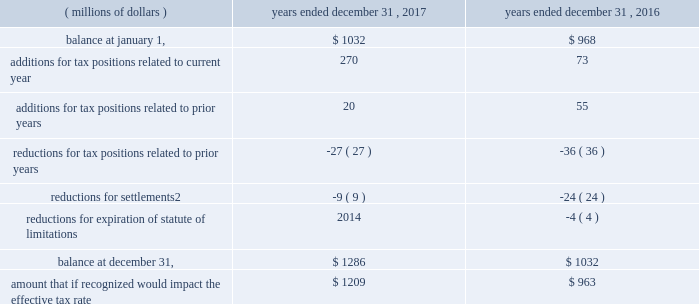82 | 2017 form 10-k a reconciliation of the beginning and ending amount of gross unrecognized tax benefits for uncertain tax positions , including positions impacting only the timing of tax benefits , follows .
Reconciliation of unrecognized tax benefits:1 years a0ended a0december a031 .
1 foreign currency impacts are included within each line as applicable .
2 includes cash payment or other reduction of assets to settle liability .
We classify interest and penalties on income taxes as a component of the provision for income taxes .
We recognized a net provision for interest and penalties of $ 38 million , $ 34 million and $ 20 million during the years ended december 31 , 2017 , 2016 and 2015 , respectively .
The total amount of interest and penalties accrued was $ 157 million and $ 120 million as of december a031 , 2017 and 2016 , respectively .
On january 31 , 2018 , we received a revenue agent 2019s report from the irs indicating the end of the field examination of our u.s .
Income tax returns for 2010 to 2012 .
In the audits of 2007 to 2012 including the impact of a loss carryback to 2005 , the irs has proposed to tax in the united states profits earned from certain parts transactions by csarl , based on the irs examination team 2019s application of the 201csubstance-over-form 201d or 201cassignment-of-income 201d judicial doctrines .
We are vigorously contesting the proposed increases to tax and penalties for these years of approximately $ 2.3 billion .
We believe that the relevant transactions complied with applicable tax laws and did not violate judicial doctrines .
We have filed u.s .
Income tax returns on this same basis for years after 2012 .
Based on the information currently available , we do not anticipate a significant increase or decrease to our unrecognized tax benefits for this matter within the next 12 months .
We currently believe the ultimate disposition of this matter will not have a material adverse effect on our consolidated financial position , liquidity or results of operations .
With the exception of a loss carryback to 2005 , tax years prior to 2007 are generally no longer subject to u.s .
Tax assessment .
In our major non-u.s .
Jurisdictions including australia , brazil , china , germany , japan , mexico , switzerland , singapore and the u.k. , tax years are typically subject to examination for three to ten years .
Due to the uncertainty related to the timing and potential outcome of audits , we cannot estimate the range of reasonably possible change in unrecognized tax benefits in the next 12 months. .
What was the average provision for interest and penalties for the period december 31 , 2015 to 2017 , in millions? 
Computations: ((20 + (38 + 34)) / 3)
Answer: 30.66667. 82 | 2017 form 10-k a reconciliation of the beginning and ending amount of gross unrecognized tax benefits for uncertain tax positions , including positions impacting only the timing of tax benefits , follows .
Reconciliation of unrecognized tax benefits:1 years a0ended a0december a031 .
1 foreign currency impacts are included within each line as applicable .
2 includes cash payment or other reduction of assets to settle liability .
We classify interest and penalties on income taxes as a component of the provision for income taxes .
We recognized a net provision for interest and penalties of $ 38 million , $ 34 million and $ 20 million during the years ended december 31 , 2017 , 2016 and 2015 , respectively .
The total amount of interest and penalties accrued was $ 157 million and $ 120 million as of december a031 , 2017 and 2016 , respectively .
On january 31 , 2018 , we received a revenue agent 2019s report from the irs indicating the end of the field examination of our u.s .
Income tax returns for 2010 to 2012 .
In the audits of 2007 to 2012 including the impact of a loss carryback to 2005 , the irs has proposed to tax in the united states profits earned from certain parts transactions by csarl , based on the irs examination team 2019s application of the 201csubstance-over-form 201d or 201cassignment-of-income 201d judicial doctrines .
We are vigorously contesting the proposed increases to tax and penalties for these years of approximately $ 2.3 billion .
We believe that the relevant transactions complied with applicable tax laws and did not violate judicial doctrines .
We have filed u.s .
Income tax returns on this same basis for years after 2012 .
Based on the information currently available , we do not anticipate a significant increase or decrease to our unrecognized tax benefits for this matter within the next 12 months .
We currently believe the ultimate disposition of this matter will not have a material adverse effect on our consolidated financial position , liquidity or results of operations .
With the exception of a loss carryback to 2005 , tax years prior to 2007 are generally no longer subject to u.s .
Tax assessment .
In our major non-u.s .
Jurisdictions including australia , brazil , china , germany , japan , mexico , switzerland , singapore and the u.k. , tax years are typically subject to examination for three to ten years .
Due to the uncertainty related to the timing and potential outcome of audits , we cannot estimate the range of reasonably possible change in unrecognized tax benefits in the next 12 months. .
What is the percentage change net provision for interest and penalties from 2015 to 2016? 
Computations: ((34 - 20) / 20)
Answer: 0.7. 